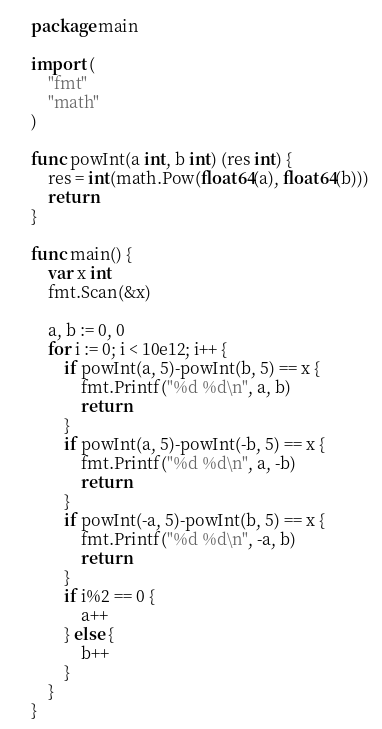<code> <loc_0><loc_0><loc_500><loc_500><_Go_>package main

import (
	"fmt"
	"math"
)

func powInt(a int, b int) (res int) {
	res = int(math.Pow(float64(a), float64(b)))
	return
}

func main() {
	var x int
	fmt.Scan(&x)

	a, b := 0, 0
	for i := 0; i < 10e12; i++ {
		if powInt(a, 5)-powInt(b, 5) == x {
			fmt.Printf("%d %d\n", a, b)
			return
		}
		if powInt(a, 5)-powInt(-b, 5) == x {
			fmt.Printf("%d %d\n", a, -b)
			return
		}
		if powInt(-a, 5)-powInt(b, 5) == x {
			fmt.Printf("%d %d\n", -a, b)
			return
		}
		if i%2 == 0 {
			a++
		} else {
			b++
		}
	}
}
</code> 